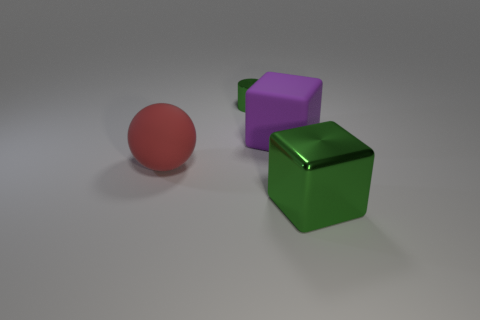There is a matte object that is right of the green metallic cylinder; is it the same size as the big red thing? yes 